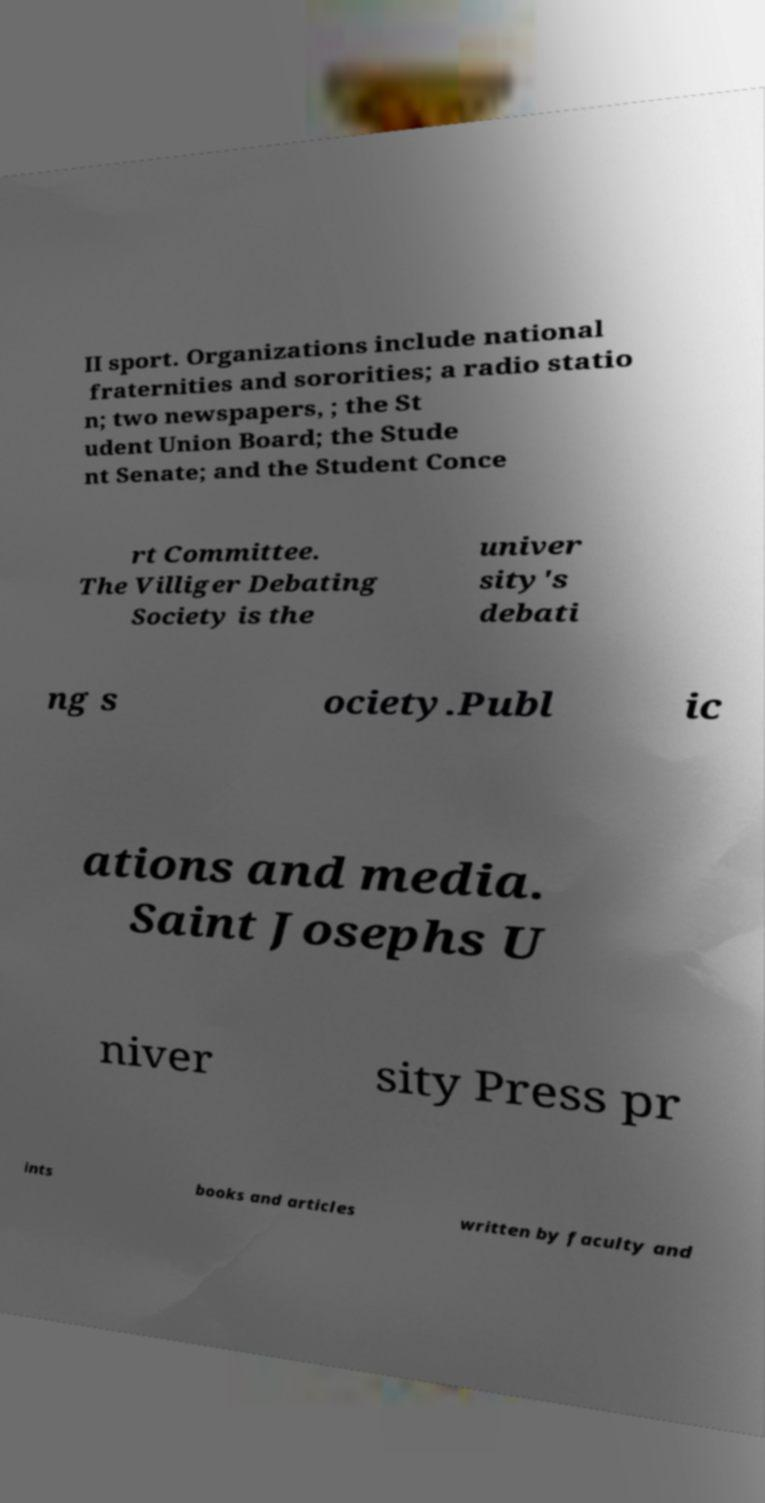For documentation purposes, I need the text within this image transcribed. Could you provide that? II sport. Organizations include national fraternities and sororities; a radio statio n; two newspapers, ; the St udent Union Board; the Stude nt Senate; and the Student Conce rt Committee. The Villiger Debating Society is the univer sity's debati ng s ociety.Publ ic ations and media. Saint Josephs U niver sity Press pr ints books and articles written by faculty and 